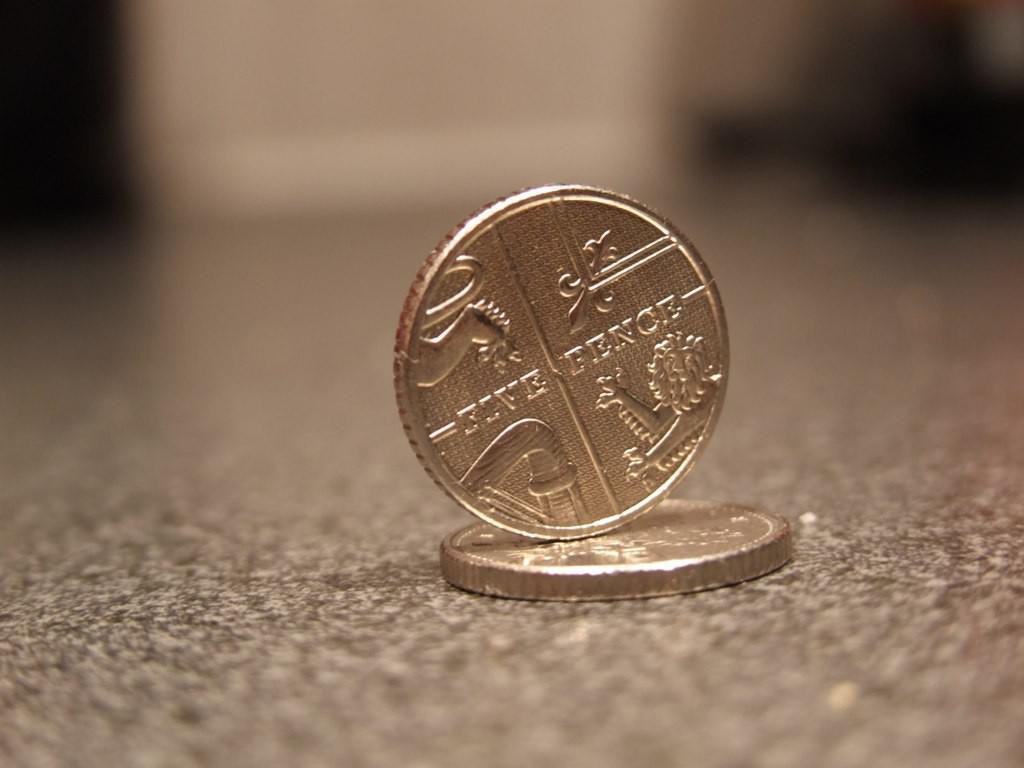What does the coin say above the lion?
Ensure brevity in your answer.  Pence. 